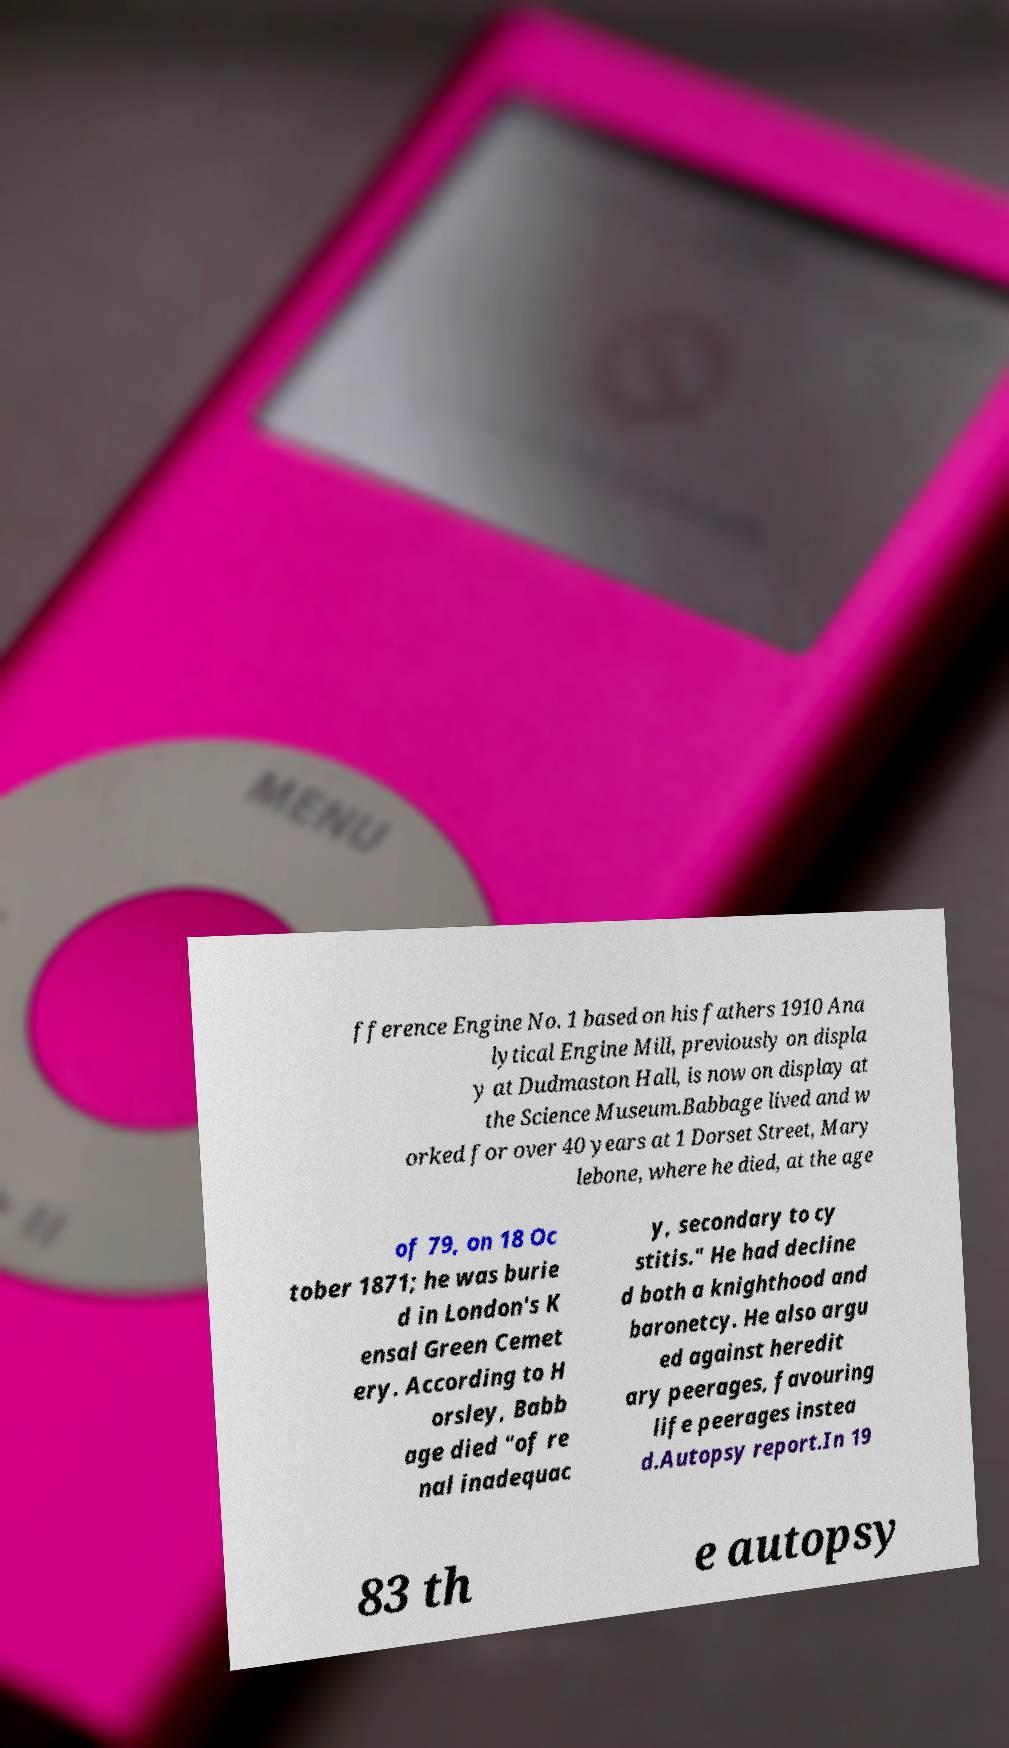For documentation purposes, I need the text within this image transcribed. Could you provide that? fference Engine No. 1 based on his fathers 1910 Ana lytical Engine Mill, previously on displa y at Dudmaston Hall, is now on display at the Science Museum.Babbage lived and w orked for over 40 years at 1 Dorset Street, Mary lebone, where he died, at the age of 79, on 18 Oc tober 1871; he was burie d in London's K ensal Green Cemet ery. According to H orsley, Babb age died "of re nal inadequac y, secondary to cy stitis." He had decline d both a knighthood and baronetcy. He also argu ed against heredit ary peerages, favouring life peerages instea d.Autopsy report.In 19 83 th e autopsy 